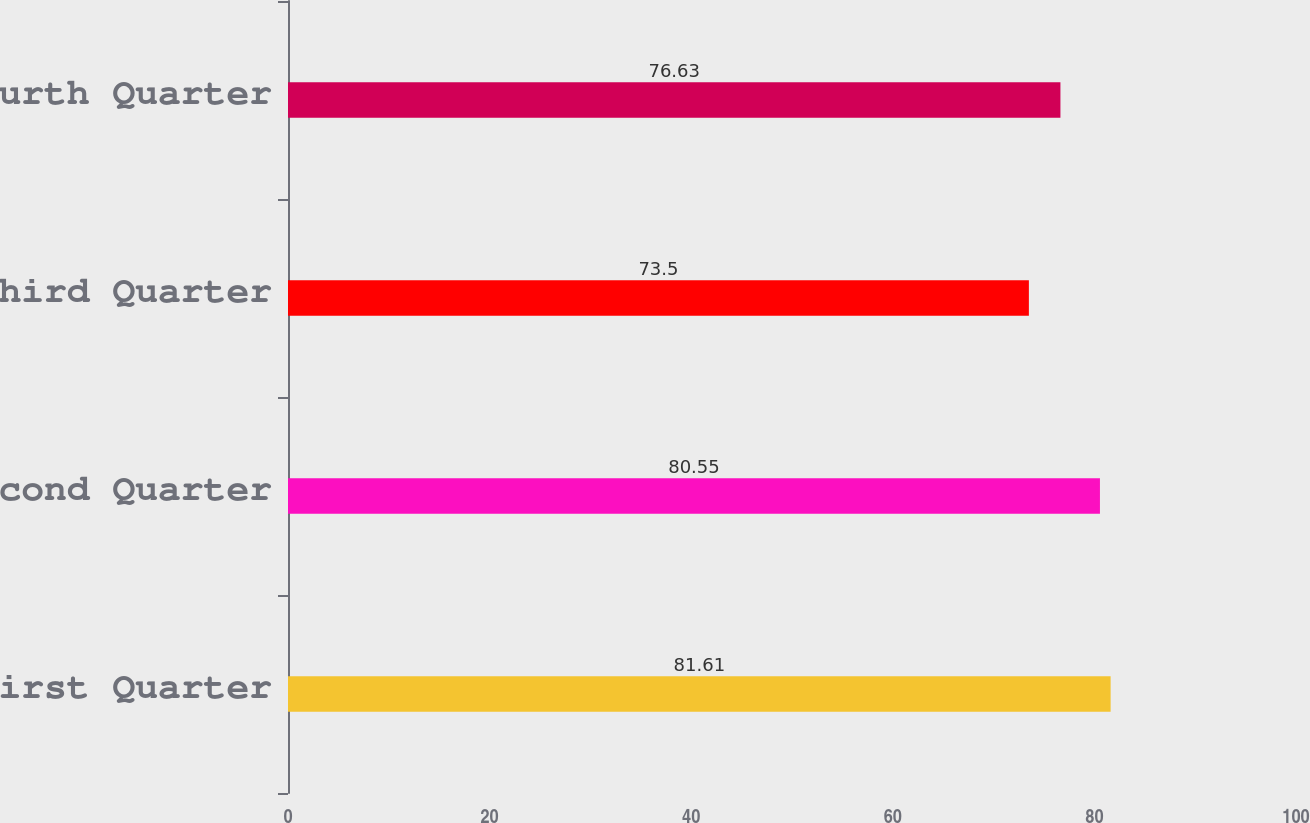Convert chart. <chart><loc_0><loc_0><loc_500><loc_500><bar_chart><fcel>First Quarter<fcel>Second Quarter<fcel>Third Quarter<fcel>Fourth Quarter<nl><fcel>81.61<fcel>80.55<fcel>73.5<fcel>76.63<nl></chart> 